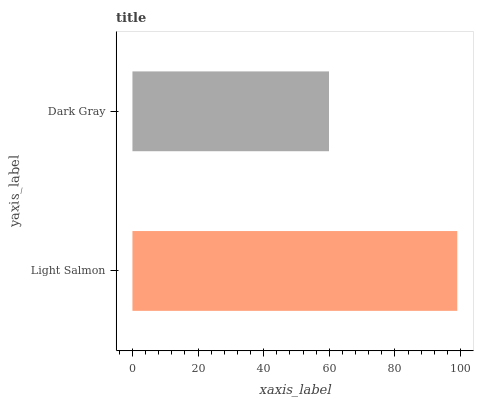Is Dark Gray the minimum?
Answer yes or no. Yes. Is Light Salmon the maximum?
Answer yes or no. Yes. Is Dark Gray the maximum?
Answer yes or no. No. Is Light Salmon greater than Dark Gray?
Answer yes or no. Yes. Is Dark Gray less than Light Salmon?
Answer yes or no. Yes. Is Dark Gray greater than Light Salmon?
Answer yes or no. No. Is Light Salmon less than Dark Gray?
Answer yes or no. No. Is Light Salmon the high median?
Answer yes or no. Yes. Is Dark Gray the low median?
Answer yes or no. Yes. Is Dark Gray the high median?
Answer yes or no. No. Is Light Salmon the low median?
Answer yes or no. No. 